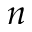<formula> <loc_0><loc_0><loc_500><loc_500>n</formula> 